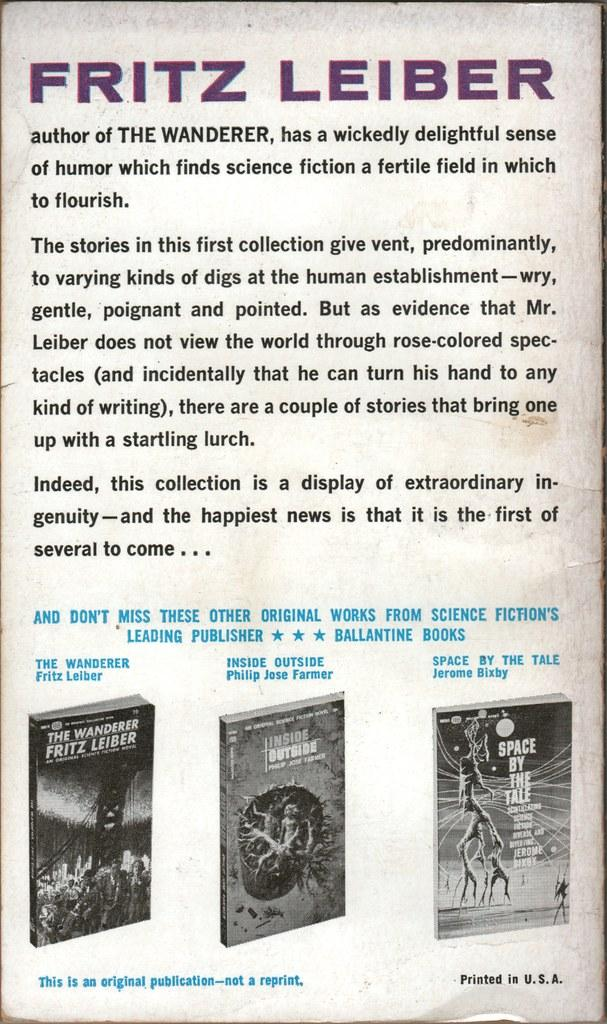<image>
Render a clear and concise summary of the photo. a poster with the name Fritz on it 